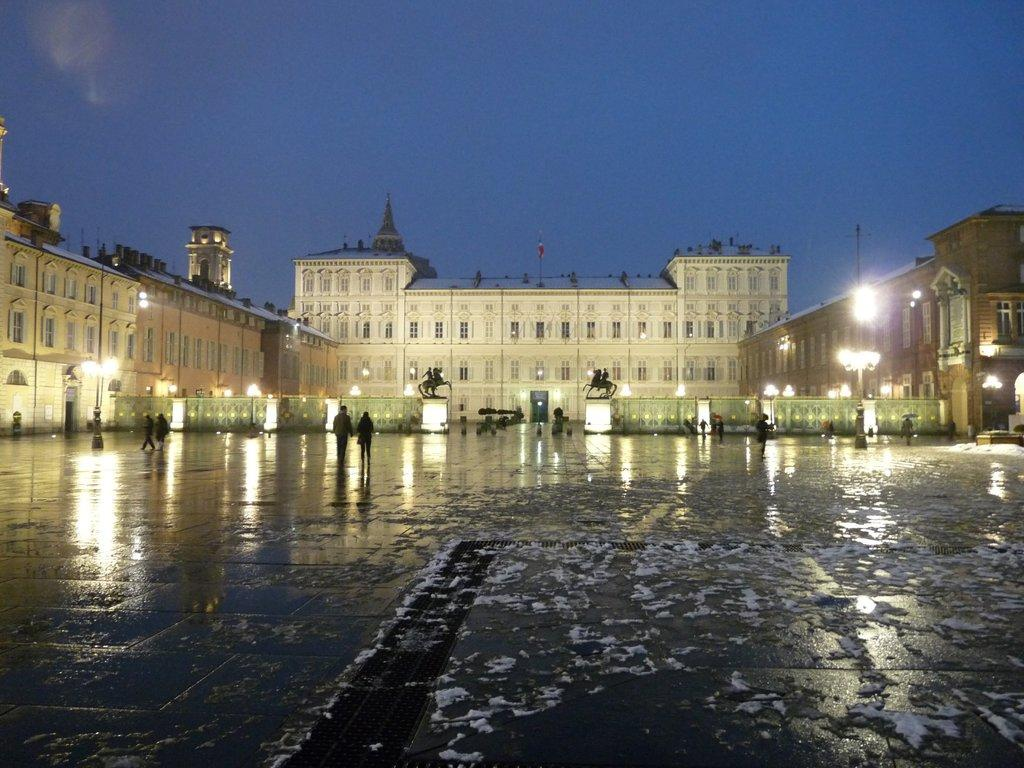What type of structure can be seen in the background of the image? There is a building in the background of the image. What are the people in the image doing? The people in the image are walking. How are the lights arranged in the image? The lights are arranged on poles in the image. What is the condition of the sky in the image? The sky is clear in the image. What color is the sweater worn by the person walking in the image? There is no information about the color of a sweater or any clothing worn by the people in the image. How many socks can be seen on the person walking in the image? There is no information about socks or any clothing worn by the people in the image. 